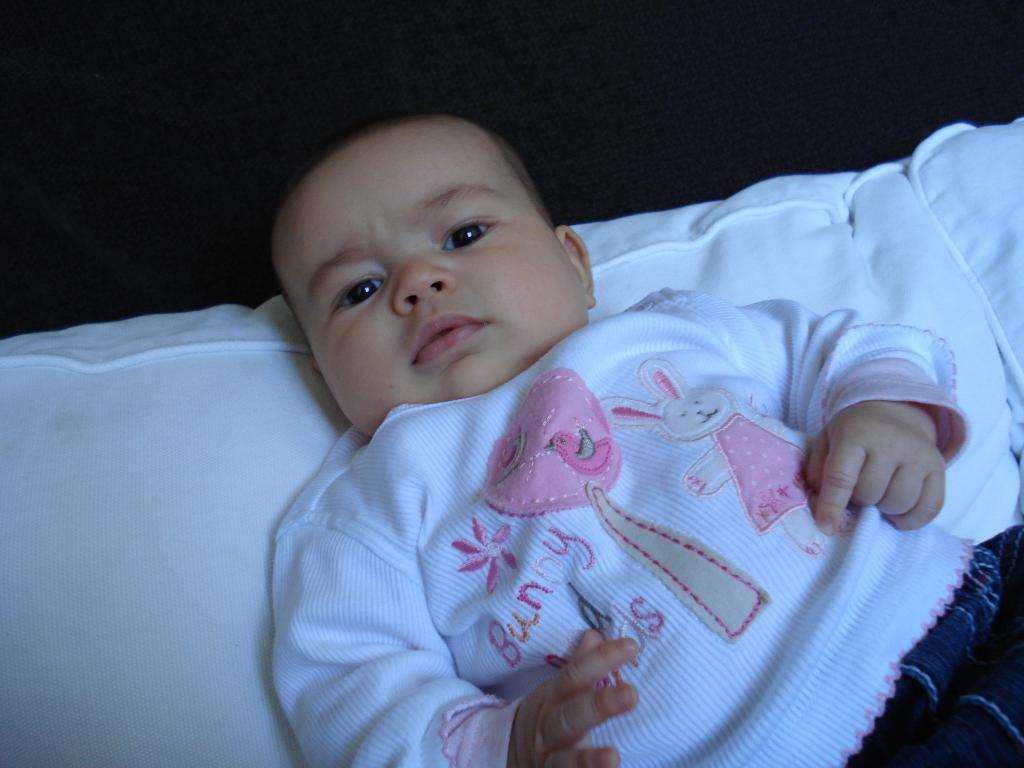What is the main subject of the picture? The main subject of the picture is a baby. Where is the baby located in the image? The baby is lying on a bed. What is the color of the bed? The bed is white in color. What is the baby wearing in the picture? The baby is wearing a white T-shirt. Can you describe the design on the T-shirt? The T-shirt has some designs on it. How much anger is visible on the baby's face in the image? The image does not show any anger on the baby's face, as it is a baby lying on a bed. Is there a hill visible in the background of the image? There is no hill visible in the background of the image; it only shows a baby lying on a white bed. 